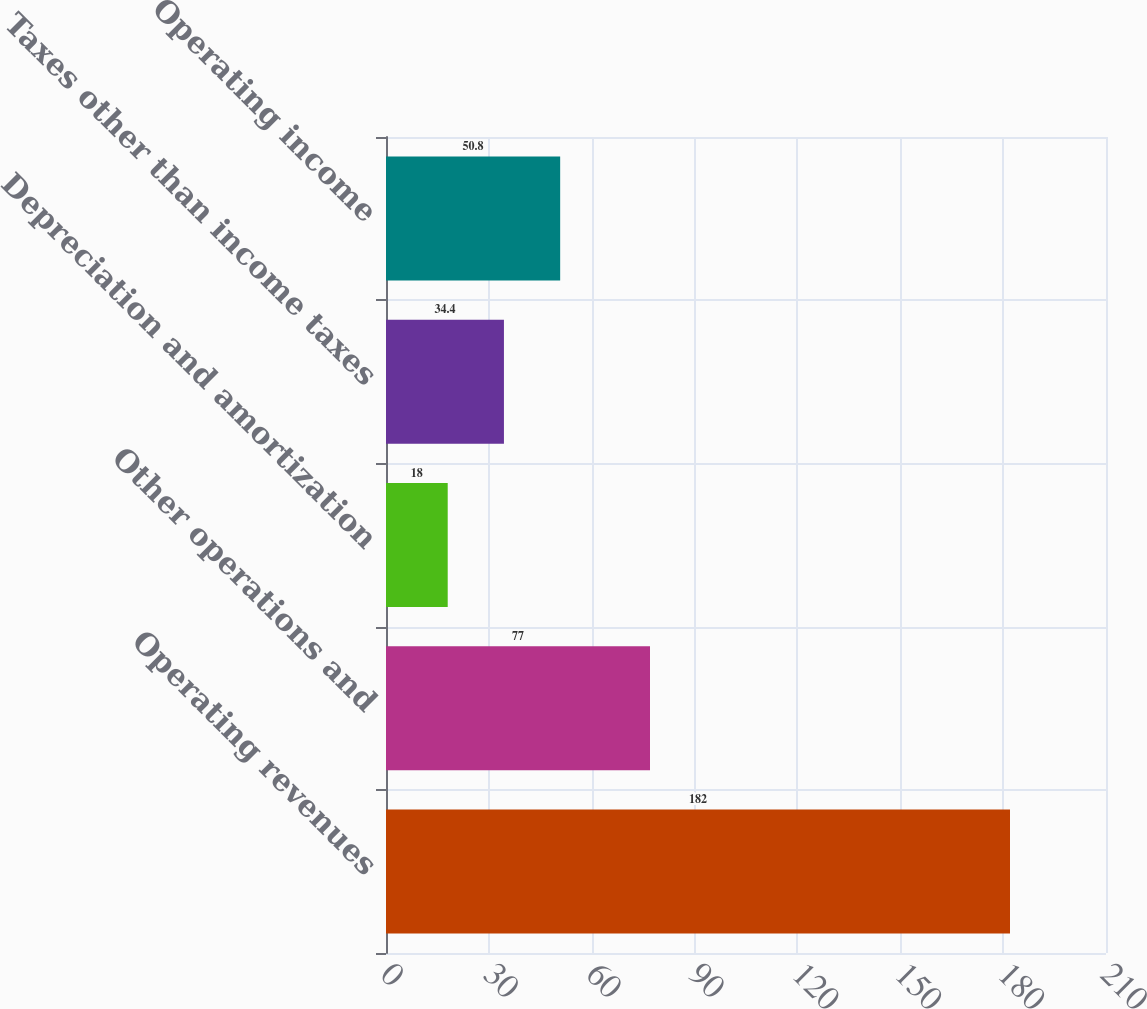<chart> <loc_0><loc_0><loc_500><loc_500><bar_chart><fcel>Operating revenues<fcel>Other operations and<fcel>Depreciation and amortization<fcel>Taxes other than income taxes<fcel>Operating income<nl><fcel>182<fcel>77<fcel>18<fcel>34.4<fcel>50.8<nl></chart> 